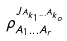Convert formula to latex. <formula><loc_0><loc_0><loc_500><loc_500>\rho _ { A _ { 1 } \dots A _ { r } } ^ { J _ { A _ { k _ { 1 } } \dots A _ { k _ { o } } } }</formula> 